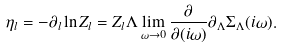<formula> <loc_0><loc_0><loc_500><loc_500>\eta _ { l } = - \partial _ { l } \ln Z _ { l } = Z _ { l } \Lambda \lim _ { \omega \rightarrow 0 } \frac { \partial } { \partial ( i \omega ) } \partial _ { \Lambda } \Sigma _ { \Lambda } ( i \omega ) .</formula> 